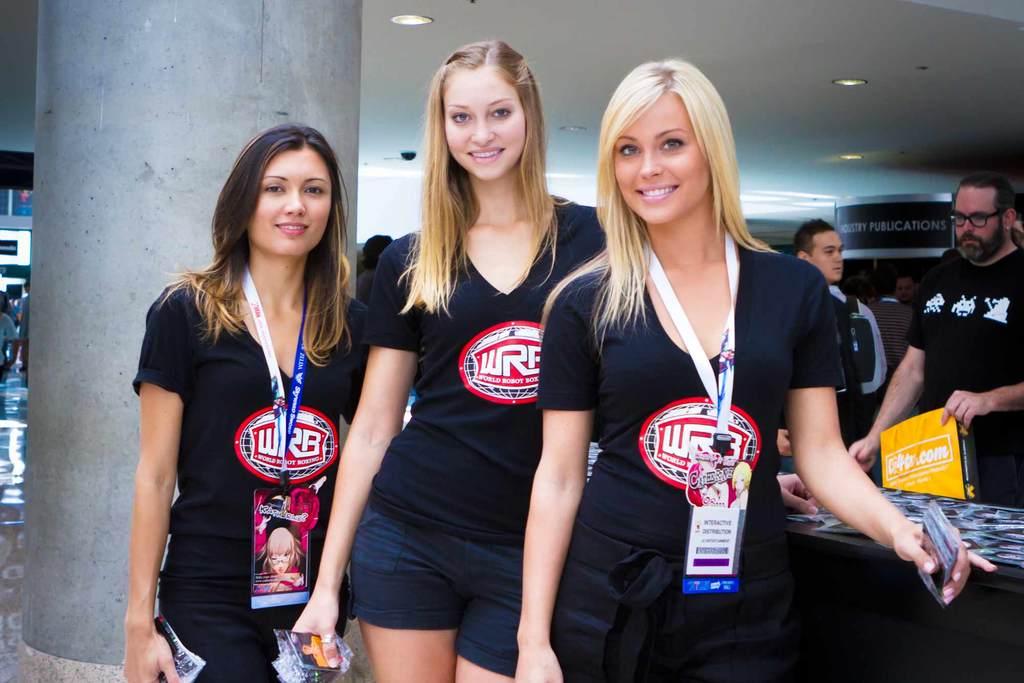What is the first letter in white on the girls' shirts?
Your response must be concise. W. 